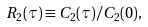Convert formula to latex. <formula><loc_0><loc_0><loc_500><loc_500>R _ { 2 } ( \tau ) \equiv C _ { 2 } ( \tau ) / C _ { 2 } ( 0 ) ,</formula> 